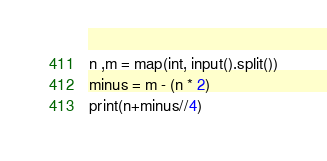<code> <loc_0><loc_0><loc_500><loc_500><_Python_>n ,m = map(int, input().split())
minus = m - (n * 2)
print(n+minus//4)</code> 